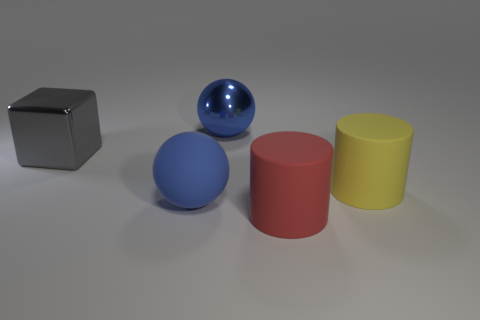Subtract all cylinders. How many objects are left? 3 Add 1 metallic spheres. How many objects exist? 6 Subtract all red cylinders. How many cylinders are left? 1 Subtract 1 spheres. How many spheres are left? 1 Add 4 tiny red metallic objects. How many tiny red metallic objects exist? 4 Subtract 0 green spheres. How many objects are left? 5 Subtract all purple cylinders. Subtract all brown spheres. How many cylinders are left? 2 Subtract all big blue cylinders. Subtract all cylinders. How many objects are left? 3 Add 3 matte things. How many matte things are left? 6 